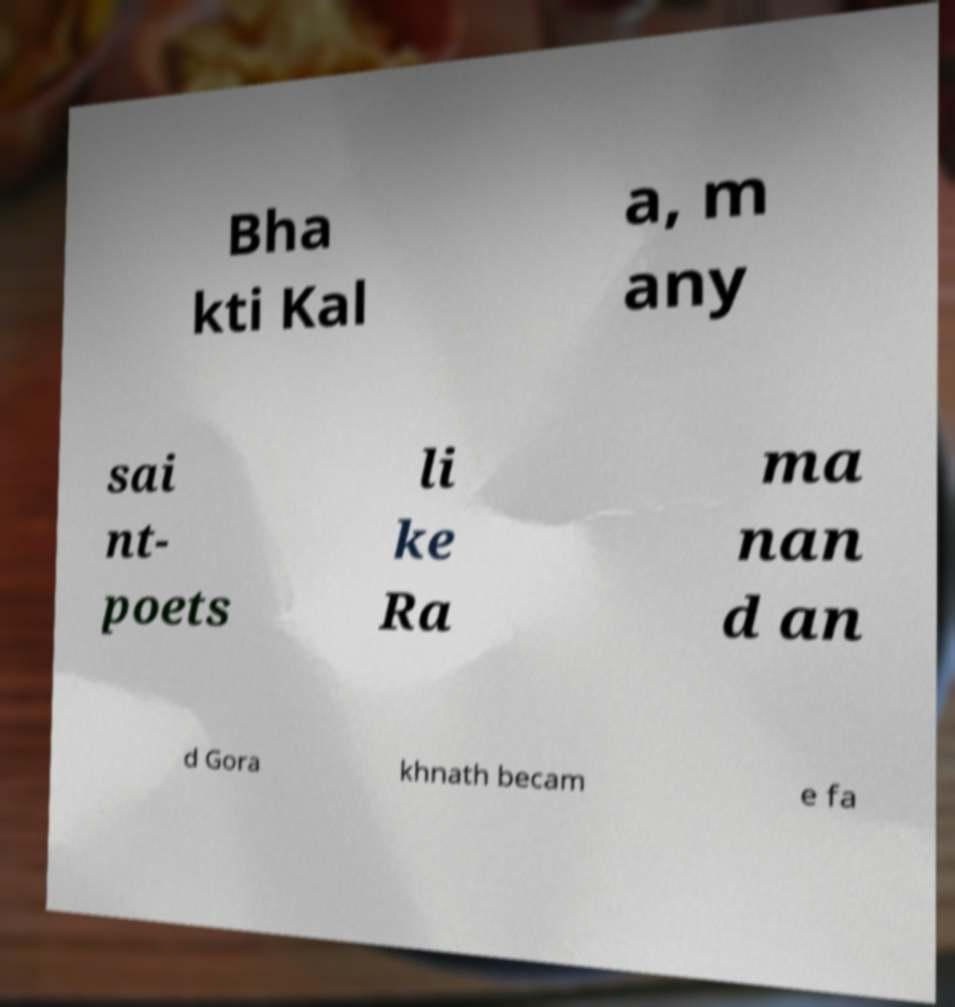Please read and relay the text visible in this image. What does it say? Bha kti Kal a, m any sai nt- poets li ke Ra ma nan d an d Gora khnath becam e fa 